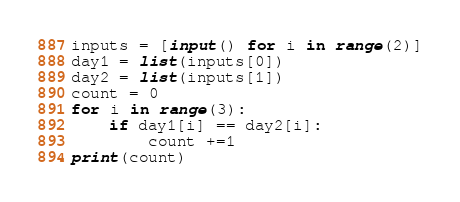Convert code to text. <code><loc_0><loc_0><loc_500><loc_500><_Python_>inputs = [input() for i in range(2)]
day1 = list(inputs[0])
day2 = list(inputs[1])
count = 0
for i in range(3):
    if day1[i] == day2[i]:
        count +=1
print(count)</code> 